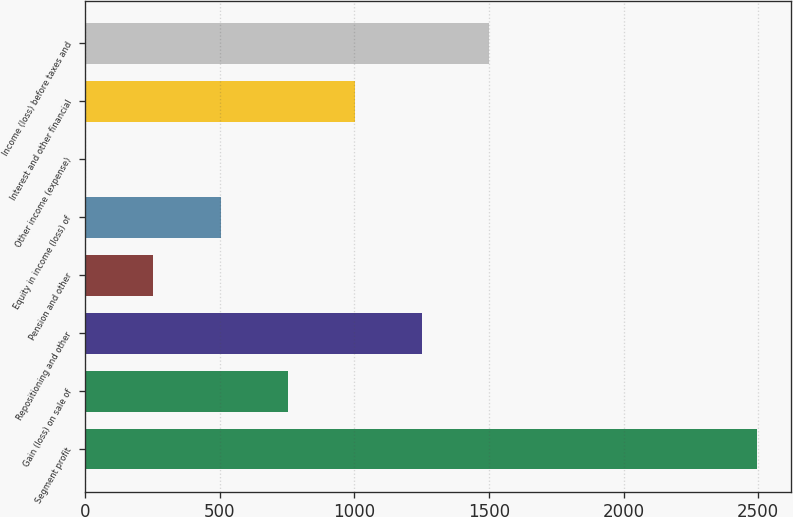Convert chart to OTSL. <chart><loc_0><loc_0><loc_500><loc_500><bar_chart><fcel>Segment profit<fcel>Gain (loss) on sale of<fcel>Repositioning and other<fcel>Pension and other<fcel>Equity in income (loss) of<fcel>Other income (expense)<fcel>Interest and other financial<fcel>Income (loss) before taxes and<nl><fcel>2497<fcel>751.9<fcel>1250.5<fcel>253.3<fcel>502.6<fcel>4<fcel>1001.2<fcel>1499.8<nl></chart> 